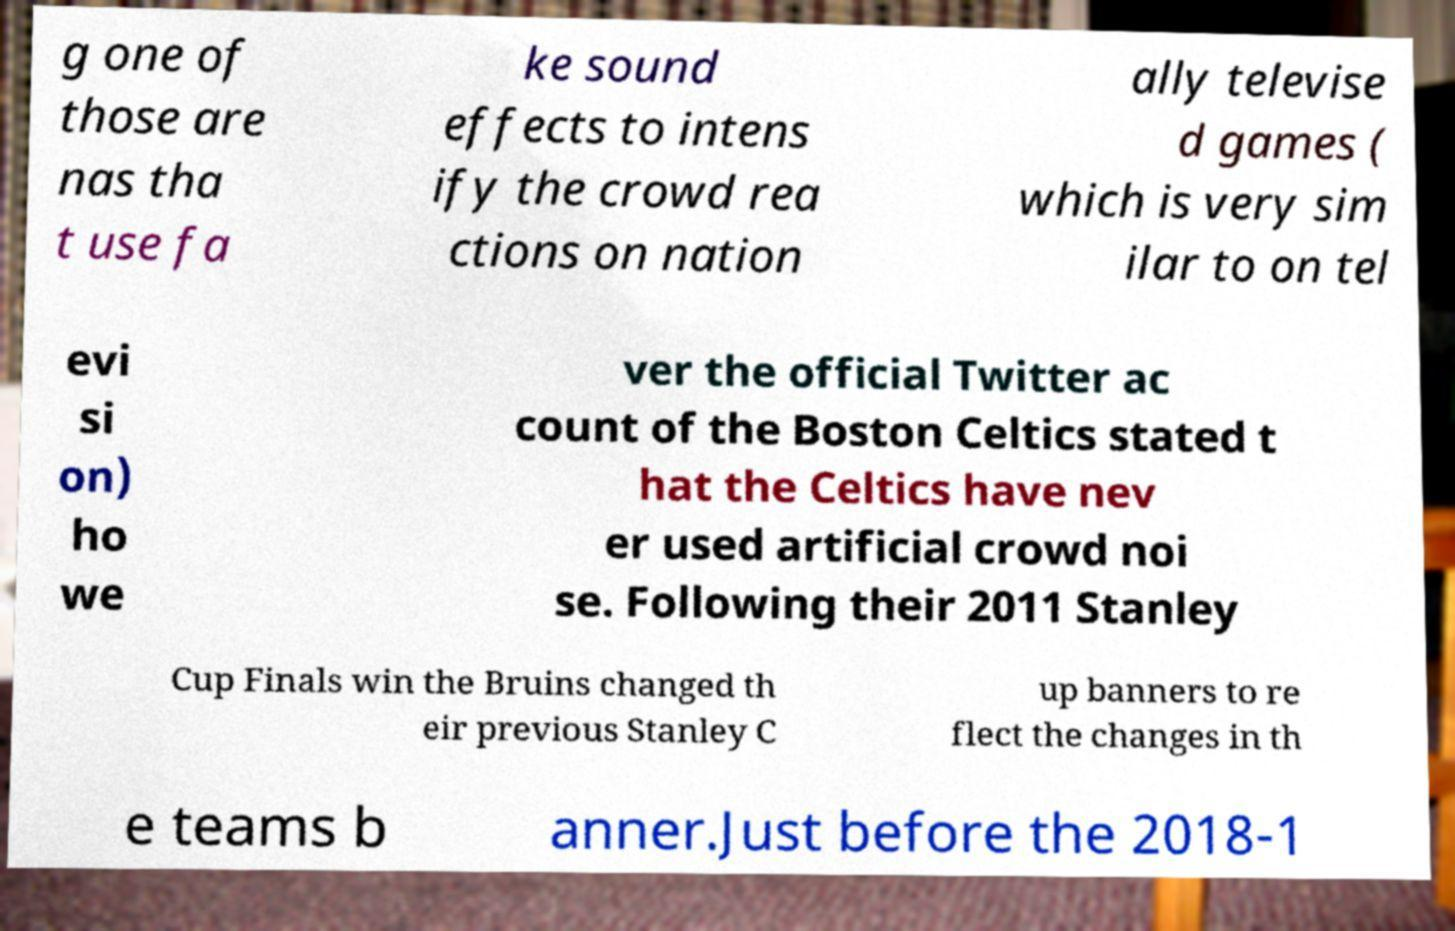For documentation purposes, I need the text within this image transcribed. Could you provide that? g one of those are nas tha t use fa ke sound effects to intens ify the crowd rea ctions on nation ally televise d games ( which is very sim ilar to on tel evi si on) ho we ver the official Twitter ac count of the Boston Celtics stated t hat the Celtics have nev er used artificial crowd noi se. Following their 2011 Stanley Cup Finals win the Bruins changed th eir previous Stanley C up banners to re flect the changes in th e teams b anner.Just before the 2018-1 